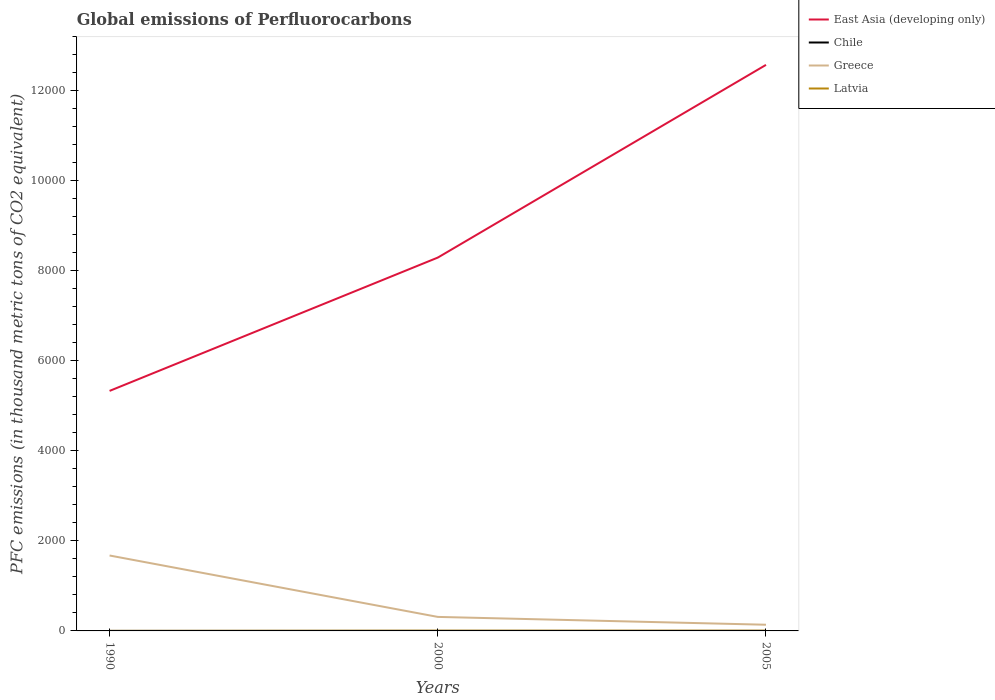Does the line corresponding to Latvia intersect with the line corresponding to Greece?
Make the answer very short. No. Across all years, what is the maximum global emissions of Perfluorocarbons in East Asia (developing only)?
Provide a short and direct response. 5333. What is the total global emissions of Perfluorocarbons in East Asia (developing only) in the graph?
Ensure brevity in your answer.  -2962.1. What is the difference between the highest and the second highest global emissions of Perfluorocarbons in Chile?
Give a very brief answer. 0. What is the difference between the highest and the lowest global emissions of Perfluorocarbons in Latvia?
Give a very brief answer. 2. Is the global emissions of Perfluorocarbons in Greece strictly greater than the global emissions of Perfluorocarbons in Latvia over the years?
Offer a very short reply. No. How many lines are there?
Ensure brevity in your answer.  4. How many years are there in the graph?
Your answer should be compact. 3. Are the values on the major ticks of Y-axis written in scientific E-notation?
Provide a short and direct response. No. Does the graph contain any zero values?
Ensure brevity in your answer.  No. Does the graph contain grids?
Ensure brevity in your answer.  No. Where does the legend appear in the graph?
Provide a succinct answer. Top right. How are the legend labels stacked?
Your answer should be very brief. Vertical. What is the title of the graph?
Provide a succinct answer. Global emissions of Perfluorocarbons. Does "Botswana" appear as one of the legend labels in the graph?
Make the answer very short. No. What is the label or title of the X-axis?
Your answer should be very brief. Years. What is the label or title of the Y-axis?
Provide a short and direct response. PFC emissions (in thousand metric tons of CO2 equivalent). What is the PFC emissions (in thousand metric tons of CO2 equivalent) in East Asia (developing only) in 1990?
Offer a terse response. 5333. What is the PFC emissions (in thousand metric tons of CO2 equivalent) in Greece in 1990?
Offer a terse response. 1675.9. What is the PFC emissions (in thousand metric tons of CO2 equivalent) in East Asia (developing only) in 2000?
Offer a very short reply. 8295.1. What is the PFC emissions (in thousand metric tons of CO2 equivalent) of Chile in 2000?
Offer a terse response. 0.2. What is the PFC emissions (in thousand metric tons of CO2 equivalent) of Greece in 2000?
Ensure brevity in your answer.  311.3. What is the PFC emissions (in thousand metric tons of CO2 equivalent) in East Asia (developing only) in 2005?
Make the answer very short. 1.26e+04. What is the PFC emissions (in thousand metric tons of CO2 equivalent) of Chile in 2005?
Ensure brevity in your answer.  0.2. What is the PFC emissions (in thousand metric tons of CO2 equivalent) of Greece in 2005?
Ensure brevity in your answer.  137.5. Across all years, what is the maximum PFC emissions (in thousand metric tons of CO2 equivalent) in East Asia (developing only)?
Provide a succinct answer. 1.26e+04. Across all years, what is the maximum PFC emissions (in thousand metric tons of CO2 equivalent) of Chile?
Give a very brief answer. 0.2. Across all years, what is the maximum PFC emissions (in thousand metric tons of CO2 equivalent) in Greece?
Your answer should be compact. 1675.9. Across all years, what is the maximum PFC emissions (in thousand metric tons of CO2 equivalent) of Latvia?
Provide a short and direct response. 5.7. Across all years, what is the minimum PFC emissions (in thousand metric tons of CO2 equivalent) in East Asia (developing only)?
Ensure brevity in your answer.  5333. Across all years, what is the minimum PFC emissions (in thousand metric tons of CO2 equivalent) in Greece?
Make the answer very short. 137.5. Across all years, what is the minimum PFC emissions (in thousand metric tons of CO2 equivalent) in Latvia?
Offer a very short reply. 0.7. What is the total PFC emissions (in thousand metric tons of CO2 equivalent) in East Asia (developing only) in the graph?
Your answer should be compact. 2.62e+04. What is the total PFC emissions (in thousand metric tons of CO2 equivalent) of Chile in the graph?
Offer a very short reply. 0.6. What is the total PFC emissions (in thousand metric tons of CO2 equivalent) in Greece in the graph?
Your answer should be very brief. 2124.7. What is the total PFC emissions (in thousand metric tons of CO2 equivalent) of Latvia in the graph?
Provide a short and direct response. 11.9. What is the difference between the PFC emissions (in thousand metric tons of CO2 equivalent) in East Asia (developing only) in 1990 and that in 2000?
Your answer should be compact. -2962.1. What is the difference between the PFC emissions (in thousand metric tons of CO2 equivalent) of Chile in 1990 and that in 2000?
Provide a short and direct response. 0. What is the difference between the PFC emissions (in thousand metric tons of CO2 equivalent) in Greece in 1990 and that in 2000?
Provide a succinct answer. 1364.6. What is the difference between the PFC emissions (in thousand metric tons of CO2 equivalent) of East Asia (developing only) in 1990 and that in 2005?
Offer a terse response. -7244.02. What is the difference between the PFC emissions (in thousand metric tons of CO2 equivalent) in Greece in 1990 and that in 2005?
Provide a short and direct response. 1538.4. What is the difference between the PFC emissions (in thousand metric tons of CO2 equivalent) in East Asia (developing only) in 2000 and that in 2005?
Make the answer very short. -4281.92. What is the difference between the PFC emissions (in thousand metric tons of CO2 equivalent) of Greece in 2000 and that in 2005?
Keep it short and to the point. 173.8. What is the difference between the PFC emissions (in thousand metric tons of CO2 equivalent) of Latvia in 2000 and that in 2005?
Ensure brevity in your answer.  0.2. What is the difference between the PFC emissions (in thousand metric tons of CO2 equivalent) in East Asia (developing only) in 1990 and the PFC emissions (in thousand metric tons of CO2 equivalent) in Chile in 2000?
Your response must be concise. 5332.8. What is the difference between the PFC emissions (in thousand metric tons of CO2 equivalent) of East Asia (developing only) in 1990 and the PFC emissions (in thousand metric tons of CO2 equivalent) of Greece in 2000?
Offer a very short reply. 5021.7. What is the difference between the PFC emissions (in thousand metric tons of CO2 equivalent) in East Asia (developing only) in 1990 and the PFC emissions (in thousand metric tons of CO2 equivalent) in Latvia in 2000?
Your response must be concise. 5327.3. What is the difference between the PFC emissions (in thousand metric tons of CO2 equivalent) in Chile in 1990 and the PFC emissions (in thousand metric tons of CO2 equivalent) in Greece in 2000?
Your answer should be very brief. -311.1. What is the difference between the PFC emissions (in thousand metric tons of CO2 equivalent) of Chile in 1990 and the PFC emissions (in thousand metric tons of CO2 equivalent) of Latvia in 2000?
Give a very brief answer. -5.5. What is the difference between the PFC emissions (in thousand metric tons of CO2 equivalent) in Greece in 1990 and the PFC emissions (in thousand metric tons of CO2 equivalent) in Latvia in 2000?
Your answer should be very brief. 1670.2. What is the difference between the PFC emissions (in thousand metric tons of CO2 equivalent) of East Asia (developing only) in 1990 and the PFC emissions (in thousand metric tons of CO2 equivalent) of Chile in 2005?
Give a very brief answer. 5332.8. What is the difference between the PFC emissions (in thousand metric tons of CO2 equivalent) of East Asia (developing only) in 1990 and the PFC emissions (in thousand metric tons of CO2 equivalent) of Greece in 2005?
Keep it short and to the point. 5195.5. What is the difference between the PFC emissions (in thousand metric tons of CO2 equivalent) of East Asia (developing only) in 1990 and the PFC emissions (in thousand metric tons of CO2 equivalent) of Latvia in 2005?
Offer a very short reply. 5327.5. What is the difference between the PFC emissions (in thousand metric tons of CO2 equivalent) in Chile in 1990 and the PFC emissions (in thousand metric tons of CO2 equivalent) in Greece in 2005?
Give a very brief answer. -137.3. What is the difference between the PFC emissions (in thousand metric tons of CO2 equivalent) of Chile in 1990 and the PFC emissions (in thousand metric tons of CO2 equivalent) of Latvia in 2005?
Give a very brief answer. -5.3. What is the difference between the PFC emissions (in thousand metric tons of CO2 equivalent) of Greece in 1990 and the PFC emissions (in thousand metric tons of CO2 equivalent) of Latvia in 2005?
Your answer should be compact. 1670.4. What is the difference between the PFC emissions (in thousand metric tons of CO2 equivalent) of East Asia (developing only) in 2000 and the PFC emissions (in thousand metric tons of CO2 equivalent) of Chile in 2005?
Provide a succinct answer. 8294.9. What is the difference between the PFC emissions (in thousand metric tons of CO2 equivalent) in East Asia (developing only) in 2000 and the PFC emissions (in thousand metric tons of CO2 equivalent) in Greece in 2005?
Your response must be concise. 8157.6. What is the difference between the PFC emissions (in thousand metric tons of CO2 equivalent) of East Asia (developing only) in 2000 and the PFC emissions (in thousand metric tons of CO2 equivalent) of Latvia in 2005?
Your answer should be very brief. 8289.6. What is the difference between the PFC emissions (in thousand metric tons of CO2 equivalent) of Chile in 2000 and the PFC emissions (in thousand metric tons of CO2 equivalent) of Greece in 2005?
Offer a very short reply. -137.3. What is the difference between the PFC emissions (in thousand metric tons of CO2 equivalent) of Chile in 2000 and the PFC emissions (in thousand metric tons of CO2 equivalent) of Latvia in 2005?
Your response must be concise. -5.3. What is the difference between the PFC emissions (in thousand metric tons of CO2 equivalent) in Greece in 2000 and the PFC emissions (in thousand metric tons of CO2 equivalent) in Latvia in 2005?
Give a very brief answer. 305.8. What is the average PFC emissions (in thousand metric tons of CO2 equivalent) in East Asia (developing only) per year?
Offer a very short reply. 8735.04. What is the average PFC emissions (in thousand metric tons of CO2 equivalent) in Chile per year?
Ensure brevity in your answer.  0.2. What is the average PFC emissions (in thousand metric tons of CO2 equivalent) of Greece per year?
Your answer should be very brief. 708.23. What is the average PFC emissions (in thousand metric tons of CO2 equivalent) of Latvia per year?
Give a very brief answer. 3.97. In the year 1990, what is the difference between the PFC emissions (in thousand metric tons of CO2 equivalent) in East Asia (developing only) and PFC emissions (in thousand metric tons of CO2 equivalent) in Chile?
Your answer should be very brief. 5332.8. In the year 1990, what is the difference between the PFC emissions (in thousand metric tons of CO2 equivalent) in East Asia (developing only) and PFC emissions (in thousand metric tons of CO2 equivalent) in Greece?
Provide a succinct answer. 3657.1. In the year 1990, what is the difference between the PFC emissions (in thousand metric tons of CO2 equivalent) of East Asia (developing only) and PFC emissions (in thousand metric tons of CO2 equivalent) of Latvia?
Offer a terse response. 5332.3. In the year 1990, what is the difference between the PFC emissions (in thousand metric tons of CO2 equivalent) of Chile and PFC emissions (in thousand metric tons of CO2 equivalent) of Greece?
Your answer should be very brief. -1675.7. In the year 1990, what is the difference between the PFC emissions (in thousand metric tons of CO2 equivalent) of Greece and PFC emissions (in thousand metric tons of CO2 equivalent) of Latvia?
Ensure brevity in your answer.  1675.2. In the year 2000, what is the difference between the PFC emissions (in thousand metric tons of CO2 equivalent) of East Asia (developing only) and PFC emissions (in thousand metric tons of CO2 equivalent) of Chile?
Provide a succinct answer. 8294.9. In the year 2000, what is the difference between the PFC emissions (in thousand metric tons of CO2 equivalent) of East Asia (developing only) and PFC emissions (in thousand metric tons of CO2 equivalent) of Greece?
Provide a short and direct response. 7983.8. In the year 2000, what is the difference between the PFC emissions (in thousand metric tons of CO2 equivalent) in East Asia (developing only) and PFC emissions (in thousand metric tons of CO2 equivalent) in Latvia?
Offer a terse response. 8289.4. In the year 2000, what is the difference between the PFC emissions (in thousand metric tons of CO2 equivalent) of Chile and PFC emissions (in thousand metric tons of CO2 equivalent) of Greece?
Offer a very short reply. -311.1. In the year 2000, what is the difference between the PFC emissions (in thousand metric tons of CO2 equivalent) of Chile and PFC emissions (in thousand metric tons of CO2 equivalent) of Latvia?
Offer a very short reply. -5.5. In the year 2000, what is the difference between the PFC emissions (in thousand metric tons of CO2 equivalent) in Greece and PFC emissions (in thousand metric tons of CO2 equivalent) in Latvia?
Give a very brief answer. 305.6. In the year 2005, what is the difference between the PFC emissions (in thousand metric tons of CO2 equivalent) of East Asia (developing only) and PFC emissions (in thousand metric tons of CO2 equivalent) of Chile?
Make the answer very short. 1.26e+04. In the year 2005, what is the difference between the PFC emissions (in thousand metric tons of CO2 equivalent) of East Asia (developing only) and PFC emissions (in thousand metric tons of CO2 equivalent) of Greece?
Your response must be concise. 1.24e+04. In the year 2005, what is the difference between the PFC emissions (in thousand metric tons of CO2 equivalent) in East Asia (developing only) and PFC emissions (in thousand metric tons of CO2 equivalent) in Latvia?
Provide a short and direct response. 1.26e+04. In the year 2005, what is the difference between the PFC emissions (in thousand metric tons of CO2 equivalent) of Chile and PFC emissions (in thousand metric tons of CO2 equivalent) of Greece?
Offer a very short reply. -137.3. In the year 2005, what is the difference between the PFC emissions (in thousand metric tons of CO2 equivalent) of Greece and PFC emissions (in thousand metric tons of CO2 equivalent) of Latvia?
Ensure brevity in your answer.  132. What is the ratio of the PFC emissions (in thousand metric tons of CO2 equivalent) in East Asia (developing only) in 1990 to that in 2000?
Provide a succinct answer. 0.64. What is the ratio of the PFC emissions (in thousand metric tons of CO2 equivalent) in Greece in 1990 to that in 2000?
Make the answer very short. 5.38. What is the ratio of the PFC emissions (in thousand metric tons of CO2 equivalent) in Latvia in 1990 to that in 2000?
Ensure brevity in your answer.  0.12. What is the ratio of the PFC emissions (in thousand metric tons of CO2 equivalent) in East Asia (developing only) in 1990 to that in 2005?
Ensure brevity in your answer.  0.42. What is the ratio of the PFC emissions (in thousand metric tons of CO2 equivalent) in Chile in 1990 to that in 2005?
Give a very brief answer. 1. What is the ratio of the PFC emissions (in thousand metric tons of CO2 equivalent) of Greece in 1990 to that in 2005?
Your response must be concise. 12.19. What is the ratio of the PFC emissions (in thousand metric tons of CO2 equivalent) in Latvia in 1990 to that in 2005?
Your response must be concise. 0.13. What is the ratio of the PFC emissions (in thousand metric tons of CO2 equivalent) of East Asia (developing only) in 2000 to that in 2005?
Ensure brevity in your answer.  0.66. What is the ratio of the PFC emissions (in thousand metric tons of CO2 equivalent) in Greece in 2000 to that in 2005?
Make the answer very short. 2.26. What is the ratio of the PFC emissions (in thousand metric tons of CO2 equivalent) in Latvia in 2000 to that in 2005?
Give a very brief answer. 1.04. What is the difference between the highest and the second highest PFC emissions (in thousand metric tons of CO2 equivalent) in East Asia (developing only)?
Provide a succinct answer. 4281.92. What is the difference between the highest and the second highest PFC emissions (in thousand metric tons of CO2 equivalent) of Chile?
Make the answer very short. 0. What is the difference between the highest and the second highest PFC emissions (in thousand metric tons of CO2 equivalent) in Greece?
Provide a short and direct response. 1364.6. What is the difference between the highest and the second highest PFC emissions (in thousand metric tons of CO2 equivalent) in Latvia?
Ensure brevity in your answer.  0.2. What is the difference between the highest and the lowest PFC emissions (in thousand metric tons of CO2 equivalent) in East Asia (developing only)?
Offer a very short reply. 7244.02. What is the difference between the highest and the lowest PFC emissions (in thousand metric tons of CO2 equivalent) in Chile?
Provide a short and direct response. 0. What is the difference between the highest and the lowest PFC emissions (in thousand metric tons of CO2 equivalent) in Greece?
Give a very brief answer. 1538.4. What is the difference between the highest and the lowest PFC emissions (in thousand metric tons of CO2 equivalent) in Latvia?
Ensure brevity in your answer.  5. 